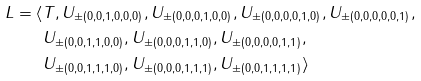Convert formula to latex. <formula><loc_0><loc_0><loc_500><loc_500>L = \langle & T , U _ { \pm ( 0 , 0 , 1 , 0 , 0 , 0 ) } , U _ { \pm ( 0 , 0 , 0 , 1 , 0 , 0 ) } , U _ { \pm ( 0 , 0 , 0 , 0 , 1 , 0 ) } , U _ { \pm ( 0 , 0 , 0 , 0 , 0 , 1 ) } , \\ & U _ { \pm ( 0 , 0 , 1 , 1 , 0 , 0 ) } , U _ { \pm ( 0 , 0 , 0 , 1 , 1 , 0 ) } , U _ { \pm ( 0 , 0 , 0 , 0 , 1 , 1 ) } , \\ & U _ { \pm ( 0 , 0 , 1 , 1 , 1 , 0 ) } , U _ { \pm ( 0 , 0 , 0 , 1 , 1 , 1 ) } , U _ { \pm ( 0 , 0 , 1 , 1 , 1 , 1 ) } \rangle</formula> 